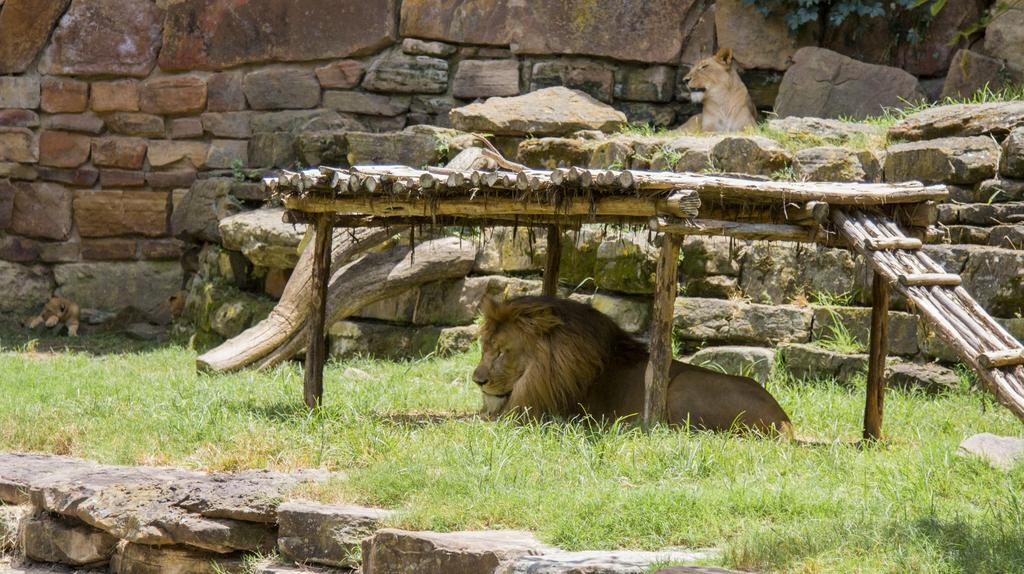What animal is the main subject of the image? There is a lion in the image. Where is the lion located in the image? The lion is at the bottom of the image. What type of vegetation can be seen in the image? There is grass in the middle of the image. What can be seen in the background of the image? There is a wall in the background of the image. What month is depicted in the image? The image does not depict a specific month; it features a lion, grass, and a wall. What unit of measurement is used to determine the size of the lion in the image? There is no unit of measurement provided in the image, and the size of the lion cannot be determined from the image alone. 